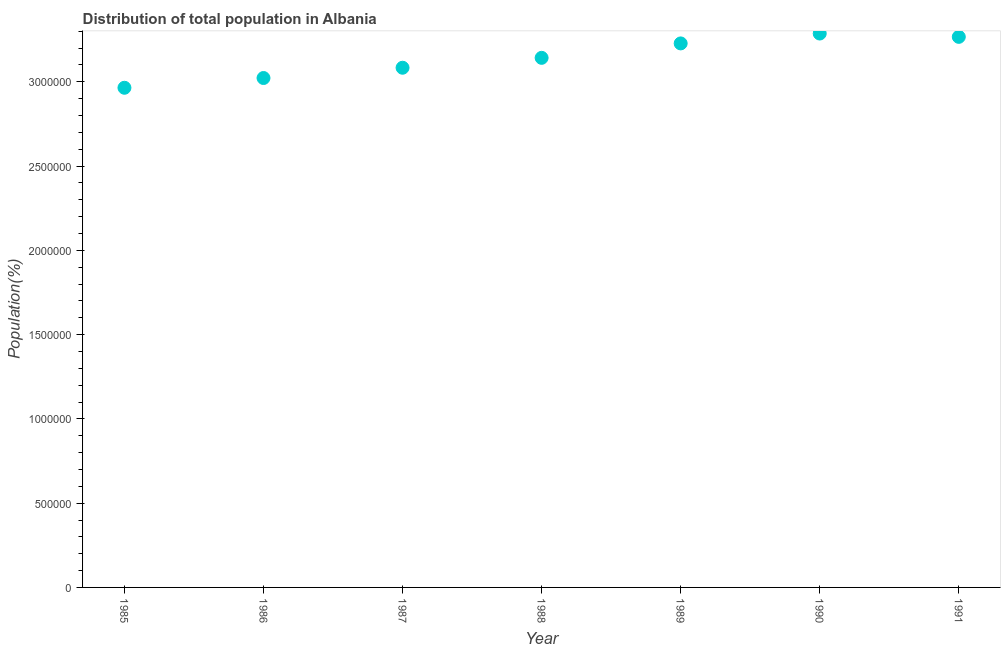What is the population in 1985?
Provide a succinct answer. 2.96e+06. Across all years, what is the maximum population?
Offer a very short reply. 3.29e+06. Across all years, what is the minimum population?
Offer a very short reply. 2.96e+06. What is the sum of the population?
Offer a very short reply. 2.20e+07. What is the difference between the population in 1987 and 1988?
Offer a very short reply. -5.87e+04. What is the average population per year?
Your answer should be very brief. 3.14e+06. What is the median population?
Your answer should be compact. 3.14e+06. What is the ratio of the population in 1988 to that in 1990?
Give a very brief answer. 0.96. What is the difference between the highest and the second highest population?
Make the answer very short. 1.98e+04. What is the difference between the highest and the lowest population?
Ensure brevity in your answer.  3.22e+05. In how many years, is the population greater than the average population taken over all years?
Your answer should be very brief. 4. Does the population monotonically increase over the years?
Offer a very short reply. No. How many dotlines are there?
Keep it short and to the point. 1. How many years are there in the graph?
Your answer should be very brief. 7. What is the difference between two consecutive major ticks on the Y-axis?
Your answer should be very brief. 5.00e+05. Does the graph contain any zero values?
Offer a very short reply. No. Does the graph contain grids?
Give a very brief answer. No. What is the title of the graph?
Provide a short and direct response. Distribution of total population in Albania . What is the label or title of the Y-axis?
Your response must be concise. Population(%). What is the Population(%) in 1985?
Your answer should be very brief. 2.96e+06. What is the Population(%) in 1986?
Your answer should be very brief. 3.02e+06. What is the Population(%) in 1987?
Give a very brief answer. 3.08e+06. What is the Population(%) in 1988?
Provide a short and direct response. 3.14e+06. What is the Population(%) in 1989?
Provide a succinct answer. 3.23e+06. What is the Population(%) in 1990?
Provide a succinct answer. 3.29e+06. What is the Population(%) in 1991?
Your answer should be very brief. 3.27e+06. What is the difference between the Population(%) in 1985 and 1986?
Give a very brief answer. -5.79e+04. What is the difference between the Population(%) in 1985 and 1987?
Ensure brevity in your answer.  -1.19e+05. What is the difference between the Population(%) in 1985 and 1988?
Provide a short and direct response. -1.78e+05. What is the difference between the Population(%) in 1985 and 1989?
Offer a terse response. -2.63e+05. What is the difference between the Population(%) in 1985 and 1990?
Keep it short and to the point. -3.22e+05. What is the difference between the Population(%) in 1985 and 1991?
Keep it short and to the point. -3.02e+05. What is the difference between the Population(%) in 1986 and 1987?
Provide a short and direct response. -6.10e+04. What is the difference between the Population(%) in 1986 and 1988?
Provide a short and direct response. -1.20e+05. What is the difference between the Population(%) in 1986 and 1989?
Your answer should be compact. -2.05e+05. What is the difference between the Population(%) in 1986 and 1990?
Offer a terse response. -2.64e+05. What is the difference between the Population(%) in 1986 and 1991?
Make the answer very short. -2.44e+05. What is the difference between the Population(%) in 1987 and 1988?
Provide a short and direct response. -5.87e+04. What is the difference between the Population(%) in 1987 and 1989?
Ensure brevity in your answer.  -1.44e+05. What is the difference between the Population(%) in 1987 and 1990?
Your answer should be very brief. -2.03e+05. What is the difference between the Population(%) in 1987 and 1991?
Your answer should be compact. -1.83e+05. What is the difference between the Population(%) in 1988 and 1989?
Ensure brevity in your answer.  -8.56e+04. What is the difference between the Population(%) in 1988 and 1990?
Provide a succinct answer. -1.44e+05. What is the difference between the Population(%) in 1988 and 1991?
Offer a terse response. -1.24e+05. What is the difference between the Population(%) in 1989 and 1990?
Keep it short and to the point. -5.86e+04. What is the difference between the Population(%) in 1989 and 1991?
Provide a short and direct response. -3.88e+04. What is the difference between the Population(%) in 1990 and 1991?
Offer a very short reply. 1.98e+04. What is the ratio of the Population(%) in 1985 to that in 1986?
Your response must be concise. 0.98. What is the ratio of the Population(%) in 1985 to that in 1988?
Ensure brevity in your answer.  0.94. What is the ratio of the Population(%) in 1985 to that in 1989?
Provide a short and direct response. 0.92. What is the ratio of the Population(%) in 1985 to that in 1990?
Provide a short and direct response. 0.9. What is the ratio of the Population(%) in 1985 to that in 1991?
Offer a very short reply. 0.91. What is the ratio of the Population(%) in 1986 to that in 1989?
Keep it short and to the point. 0.94. What is the ratio of the Population(%) in 1986 to that in 1991?
Offer a very short reply. 0.93. What is the ratio of the Population(%) in 1987 to that in 1989?
Offer a very short reply. 0.95. What is the ratio of the Population(%) in 1987 to that in 1990?
Your answer should be very brief. 0.94. What is the ratio of the Population(%) in 1987 to that in 1991?
Offer a terse response. 0.94. What is the ratio of the Population(%) in 1988 to that in 1990?
Make the answer very short. 0.96. What is the ratio of the Population(%) in 1988 to that in 1991?
Offer a terse response. 0.96. What is the ratio of the Population(%) in 1989 to that in 1991?
Your response must be concise. 0.99. What is the ratio of the Population(%) in 1990 to that in 1991?
Offer a terse response. 1.01. 